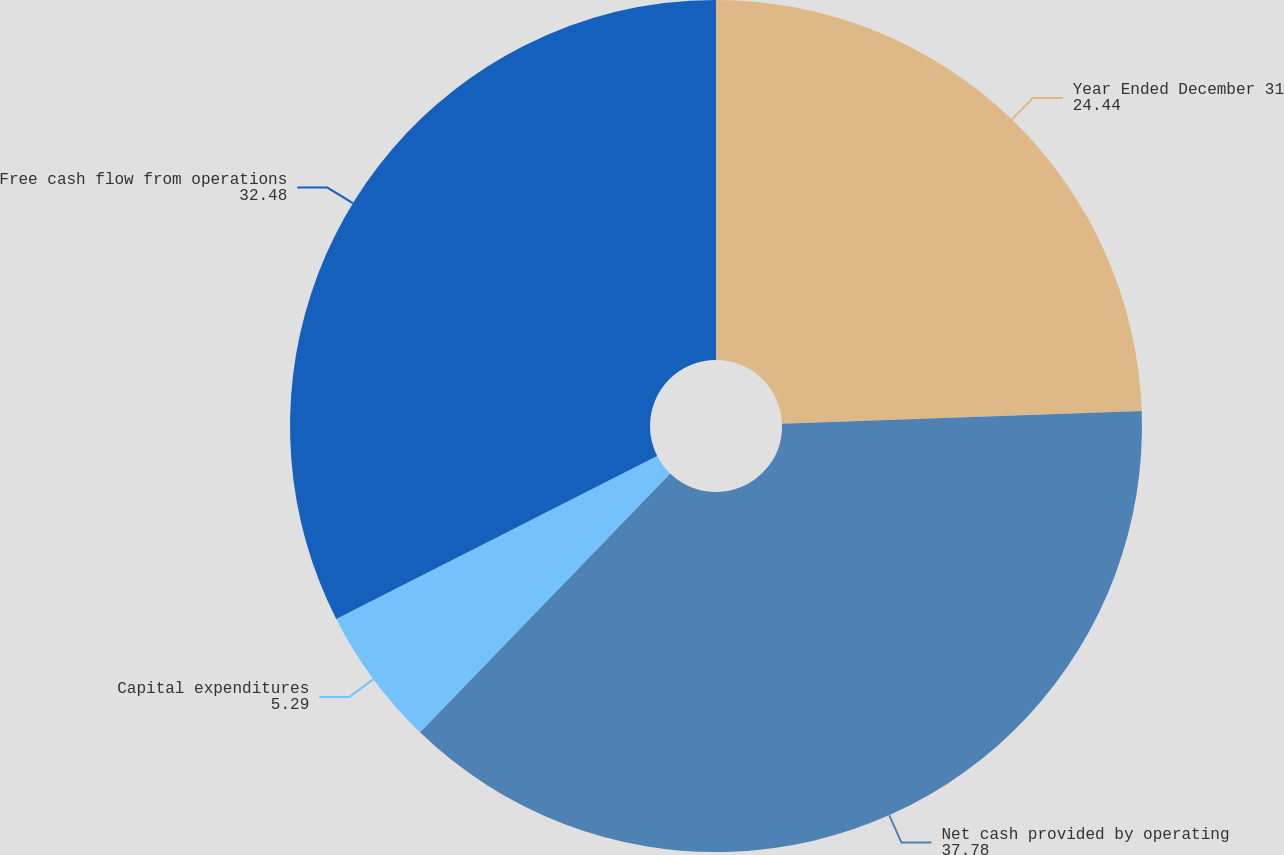<chart> <loc_0><loc_0><loc_500><loc_500><pie_chart><fcel>Year Ended December 31<fcel>Net cash provided by operating<fcel>Capital expenditures<fcel>Free cash flow from operations<nl><fcel>24.44%<fcel>37.78%<fcel>5.29%<fcel>32.48%<nl></chart> 